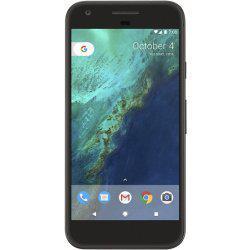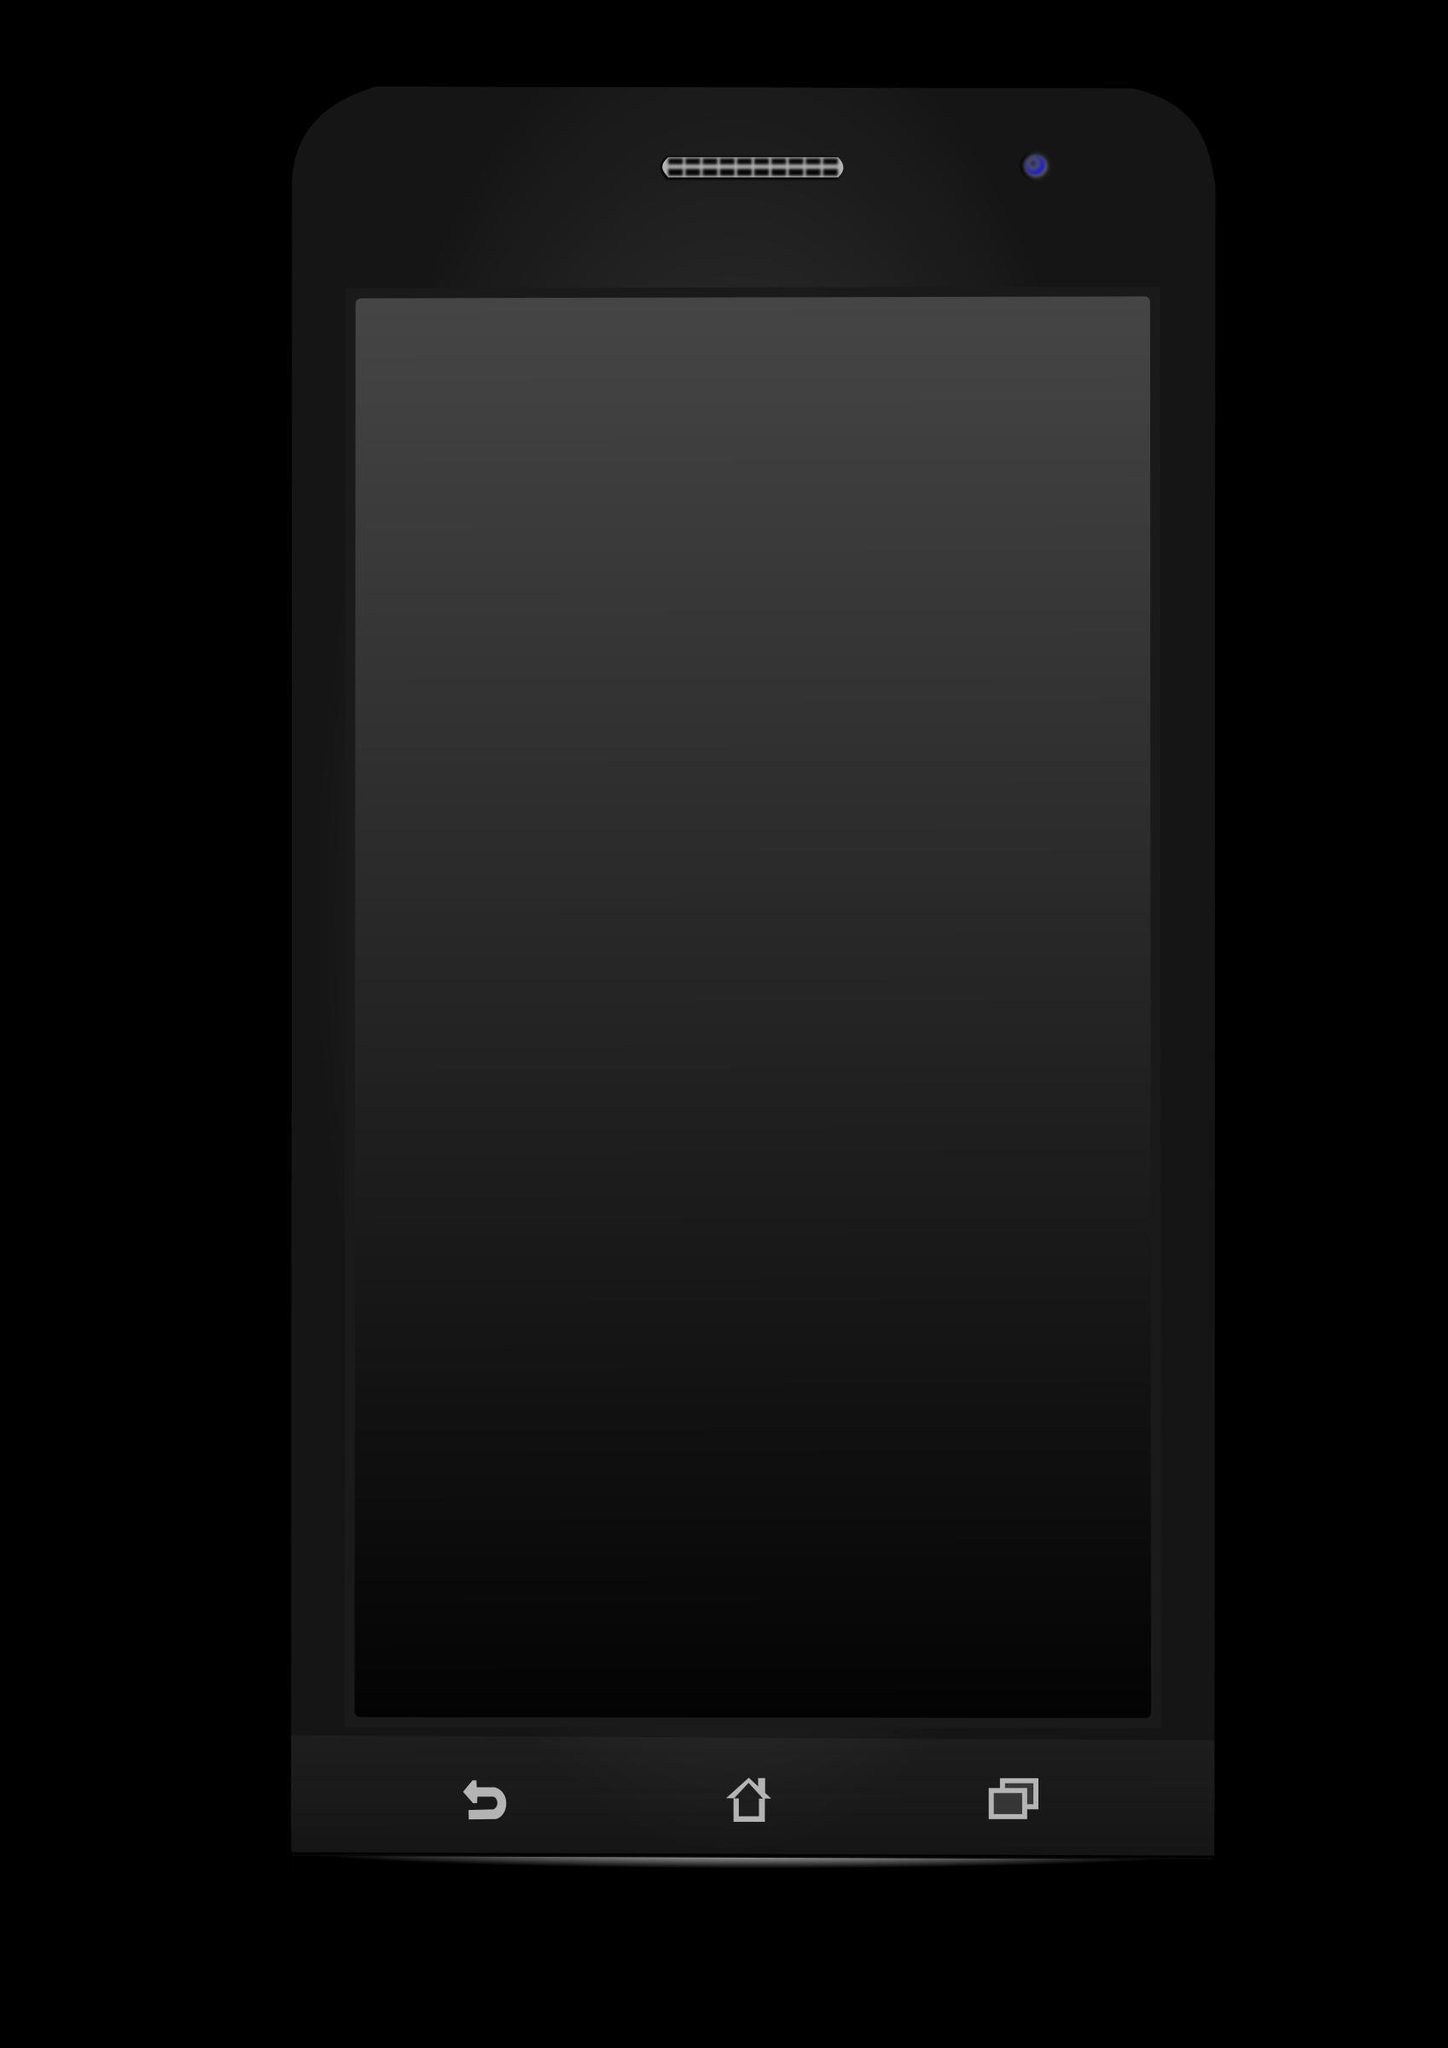The first image is the image on the left, the second image is the image on the right. Evaluate the accuracy of this statement regarding the images: "The right image contains one smart phone with a black screen.". Is it true? Answer yes or no. Yes. The first image is the image on the left, the second image is the image on the right. For the images shown, is this caption "One of the phones is turned off, with a blank screen." true? Answer yes or no. Yes. 